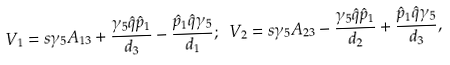Convert formula to latex. <formula><loc_0><loc_0><loc_500><loc_500>V _ { 1 } = s \gamma _ { 5 } A _ { 1 3 } + \frac { \gamma _ { 5 } \hat { q } \hat { p } _ { 1 } } { d _ { 3 } } - \frac { \hat { p } _ { 1 } \hat { q } \gamma _ { 5 } } { d _ { 1 } } ; \ V _ { 2 } = s \gamma _ { 5 } A _ { 2 3 } - \frac { \gamma _ { 5 } \hat { q } \hat { p } _ { 1 } } { d _ { 2 } } + \frac { \hat { p } _ { 1 } \hat { q } \gamma _ { 5 } } { d _ { 3 } } ,</formula> 